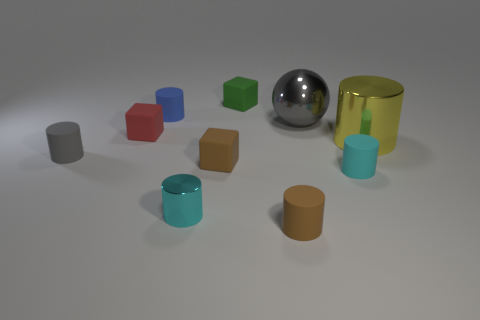What number of matte cylinders are the same size as the blue matte object?
Offer a very short reply. 3. What is the size of the rubber object that is the same color as the metallic sphere?
Offer a terse response. Small. Are there any tiny metallic things of the same color as the big metal cylinder?
Keep it short and to the point. No. What color is the shiny thing that is the same size as the red cube?
Offer a very short reply. Cyan. Do the metal ball and the shiny object in front of the large shiny cylinder have the same color?
Keep it short and to the point. No. What is the color of the large metallic cylinder?
Keep it short and to the point. Yellow. What material is the block left of the tiny metallic thing?
Make the answer very short. Rubber. What is the size of the brown matte object that is the same shape as the small red rubber object?
Your response must be concise. Small. Is the number of gray rubber objects that are to the right of the metallic ball less than the number of green cubes?
Give a very brief answer. Yes. Are any brown blocks visible?
Provide a succinct answer. Yes. 